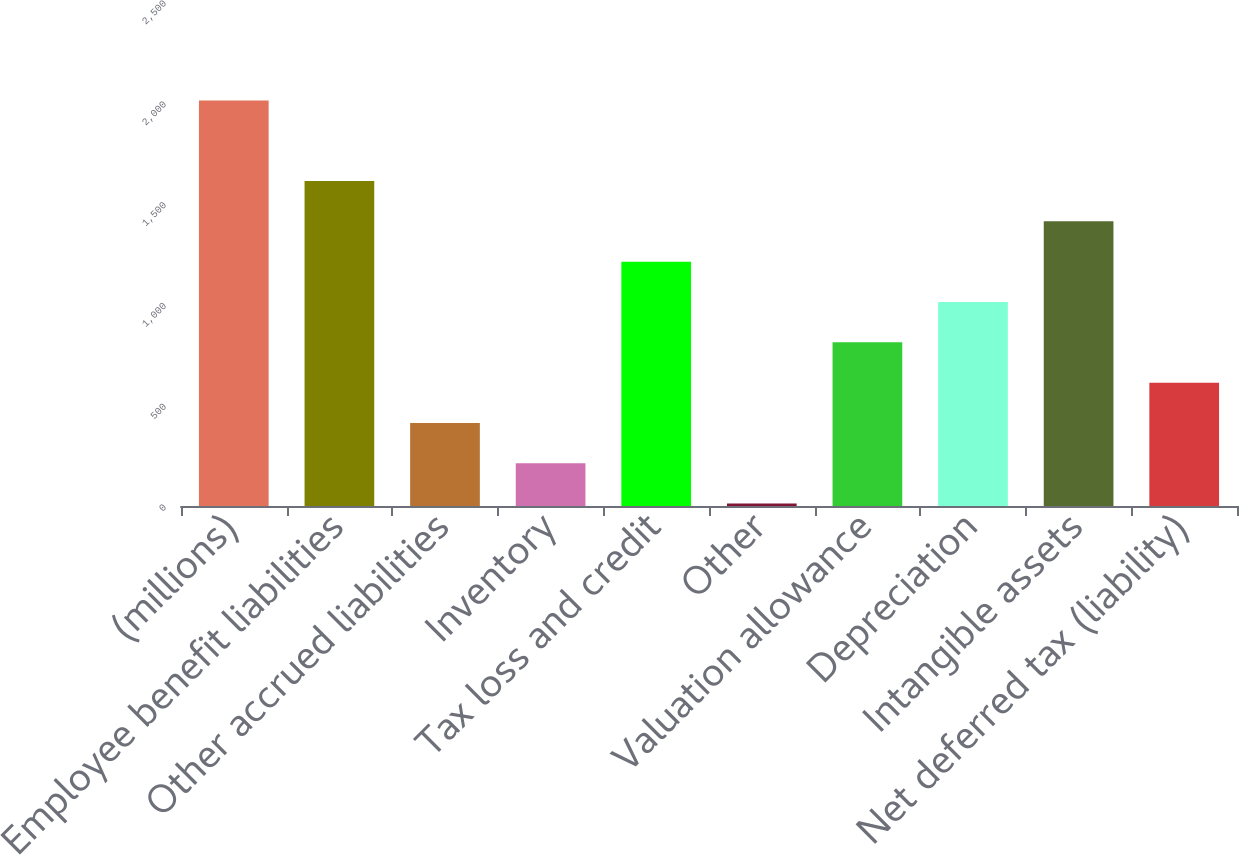<chart> <loc_0><loc_0><loc_500><loc_500><bar_chart><fcel>(millions)<fcel>Employee benefit liabilities<fcel>Other accrued liabilities<fcel>Inventory<fcel>Tax loss and credit<fcel>Other<fcel>Valuation allowance<fcel>Depreciation<fcel>Intangible assets<fcel>Net deferred tax (liability)<nl><fcel>2012<fcel>1611.96<fcel>411.84<fcel>211.82<fcel>1211.92<fcel>11.8<fcel>811.88<fcel>1011.9<fcel>1411.94<fcel>611.86<nl></chart> 